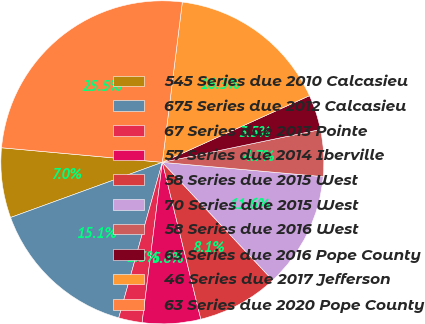Convert chart. <chart><loc_0><loc_0><loc_500><loc_500><pie_chart><fcel>545 Series due 2010 Calcasieu<fcel>675 Series due 2012 Calcasieu<fcel>67 Series due 2013 Pointe<fcel>57 Series due 2014 Iberville<fcel>58 Series due 2015 West<fcel>70 Series due 2015 West<fcel>58 Series due 2016 West<fcel>63 Series due 2016 Pope County<fcel>46 Series due 2017 Jefferson<fcel>63 Series due 2020 Pope County<nl><fcel>6.99%<fcel>15.1%<fcel>2.35%<fcel>5.83%<fcel>8.14%<fcel>11.62%<fcel>4.67%<fcel>3.51%<fcel>16.26%<fcel>25.54%<nl></chart> 